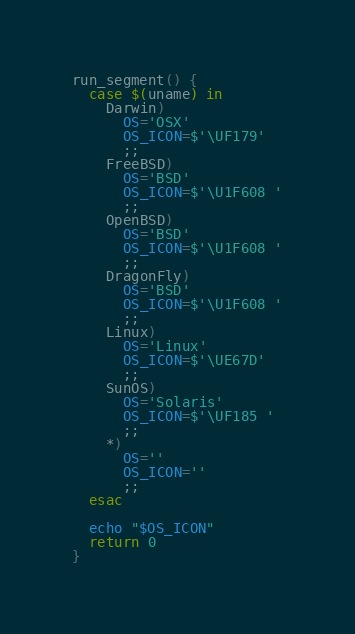<code> <loc_0><loc_0><loc_500><loc_500><_Bash_>run_segment() {
  case $(uname) in
    Darwin)
      OS='OSX'
      OS_ICON=$'\UF179'
      ;;
    FreeBSD)
      OS='BSD'
      OS_ICON=$'\U1F608 '
      ;;
    OpenBSD)
      OS='BSD'
      OS_ICON=$'\U1F608 '
      ;;
    DragonFly)
      OS='BSD'
      OS_ICON=$'\U1F608 '
      ;;
    Linux)
      OS='Linux'
      OS_ICON=$'\UE67D'
      ;;
    SunOS)
      OS='Solaris'
      OS_ICON=$'\UF185 '
      ;;
    *)
      OS=''
      OS_ICON=''
      ;;
  esac

  echo "$OS_ICON"
  return 0
}
</code> 